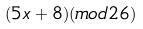Convert formula to latex. <formula><loc_0><loc_0><loc_500><loc_500>( 5 x + 8 ) ( m o d 2 6 )</formula> 